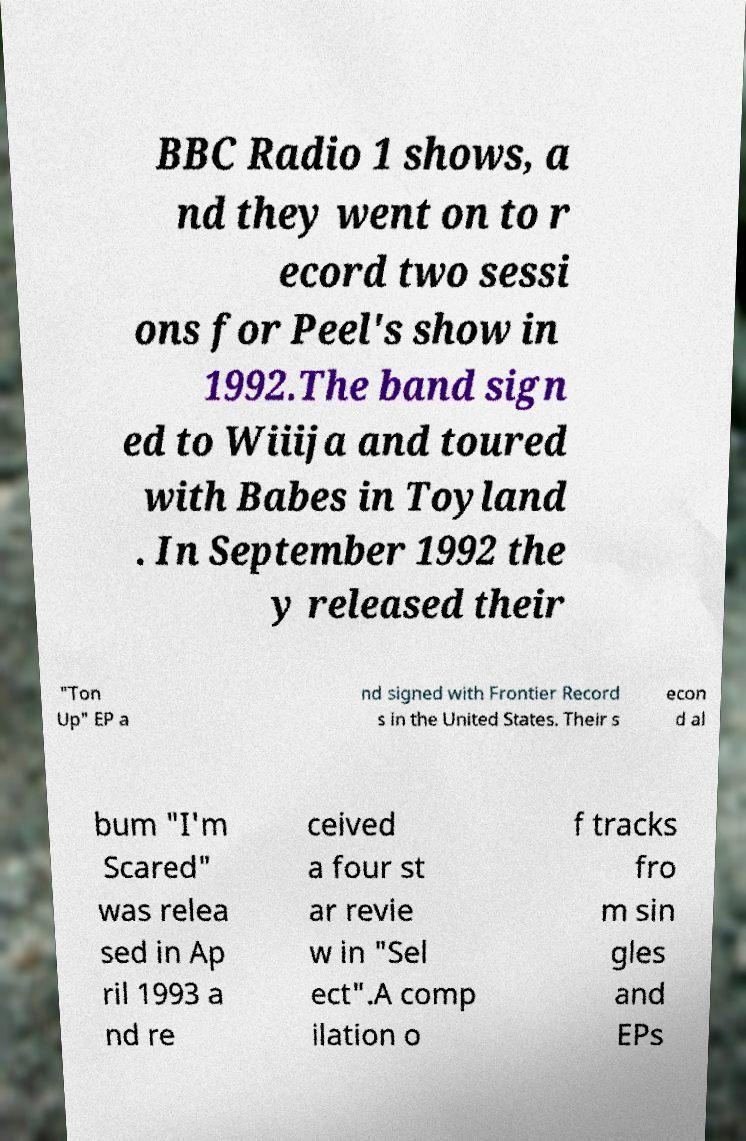For documentation purposes, I need the text within this image transcribed. Could you provide that? BBC Radio 1 shows, a nd they went on to r ecord two sessi ons for Peel's show in 1992.The band sign ed to Wiiija and toured with Babes in Toyland . In September 1992 the y released their "Ton Up" EP a nd signed with Frontier Record s in the United States. Their s econ d al bum "I'm Scared" was relea sed in Ap ril 1993 a nd re ceived a four st ar revie w in "Sel ect".A comp ilation o f tracks fro m sin gles and EPs 